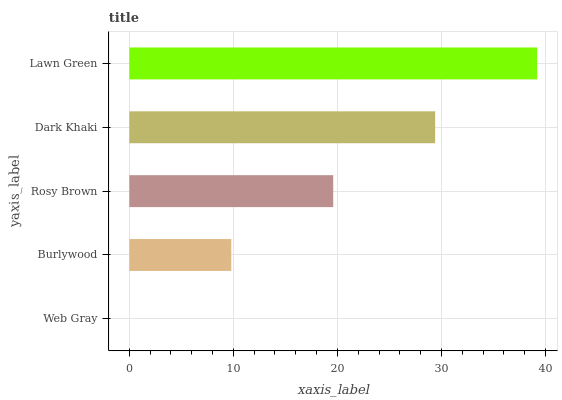Is Web Gray the minimum?
Answer yes or no. Yes. Is Lawn Green the maximum?
Answer yes or no. Yes. Is Burlywood the minimum?
Answer yes or no. No. Is Burlywood the maximum?
Answer yes or no. No. Is Burlywood greater than Web Gray?
Answer yes or no. Yes. Is Web Gray less than Burlywood?
Answer yes or no. Yes. Is Web Gray greater than Burlywood?
Answer yes or no. No. Is Burlywood less than Web Gray?
Answer yes or no. No. Is Rosy Brown the high median?
Answer yes or no. Yes. Is Rosy Brown the low median?
Answer yes or no. Yes. Is Web Gray the high median?
Answer yes or no. No. Is Web Gray the low median?
Answer yes or no. No. 